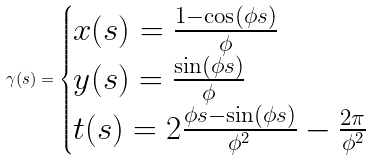Convert formula to latex. <formula><loc_0><loc_0><loc_500><loc_500>\gamma ( s ) = \begin{cases} x ( s ) = \frac { 1 - \cos ( \phi s ) } { \phi } \\ y ( s ) = \frac { \sin ( \phi s ) } { \phi } \\ t ( s ) = 2 \frac { \phi s - \sin ( \phi s ) } { \phi ^ { 2 } } - \frac { 2 \pi } { \phi ^ { 2 } } \end{cases}</formula> 